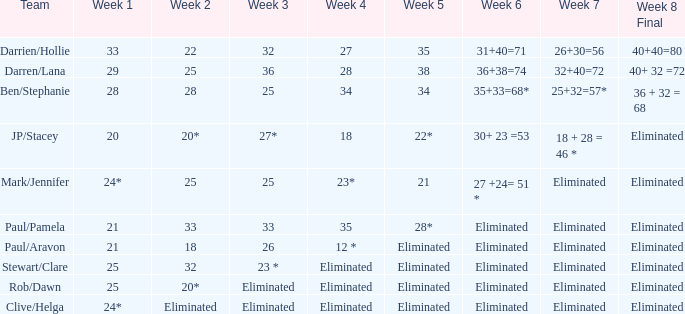Name the team for week 1 of 33 Darrien/Hollie. 